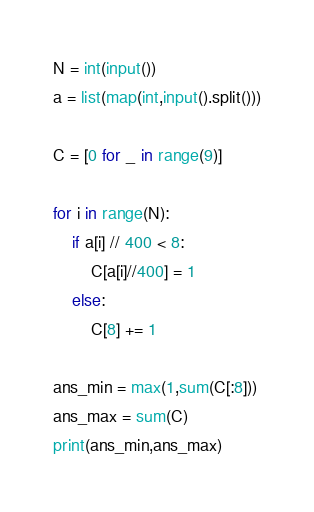<code> <loc_0><loc_0><loc_500><loc_500><_Python_>N = int(input())
a = list(map(int,input().split()))

C = [0 for _ in range(9)]

for i in range(N):
    if a[i] // 400 < 8:
        C[a[i]//400] = 1
    else:
        C[8] += 1

ans_min = max(1,sum(C[:8]))
ans_max = sum(C)
print(ans_min,ans_max)
</code> 